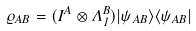Convert formula to latex. <formula><loc_0><loc_0><loc_500><loc_500>\varrho _ { A B } = ( I ^ { A } \otimes \Lambda ^ { B } _ { 1 } ) | \psi _ { A B } \rangle \langle \psi _ { A B } |</formula> 